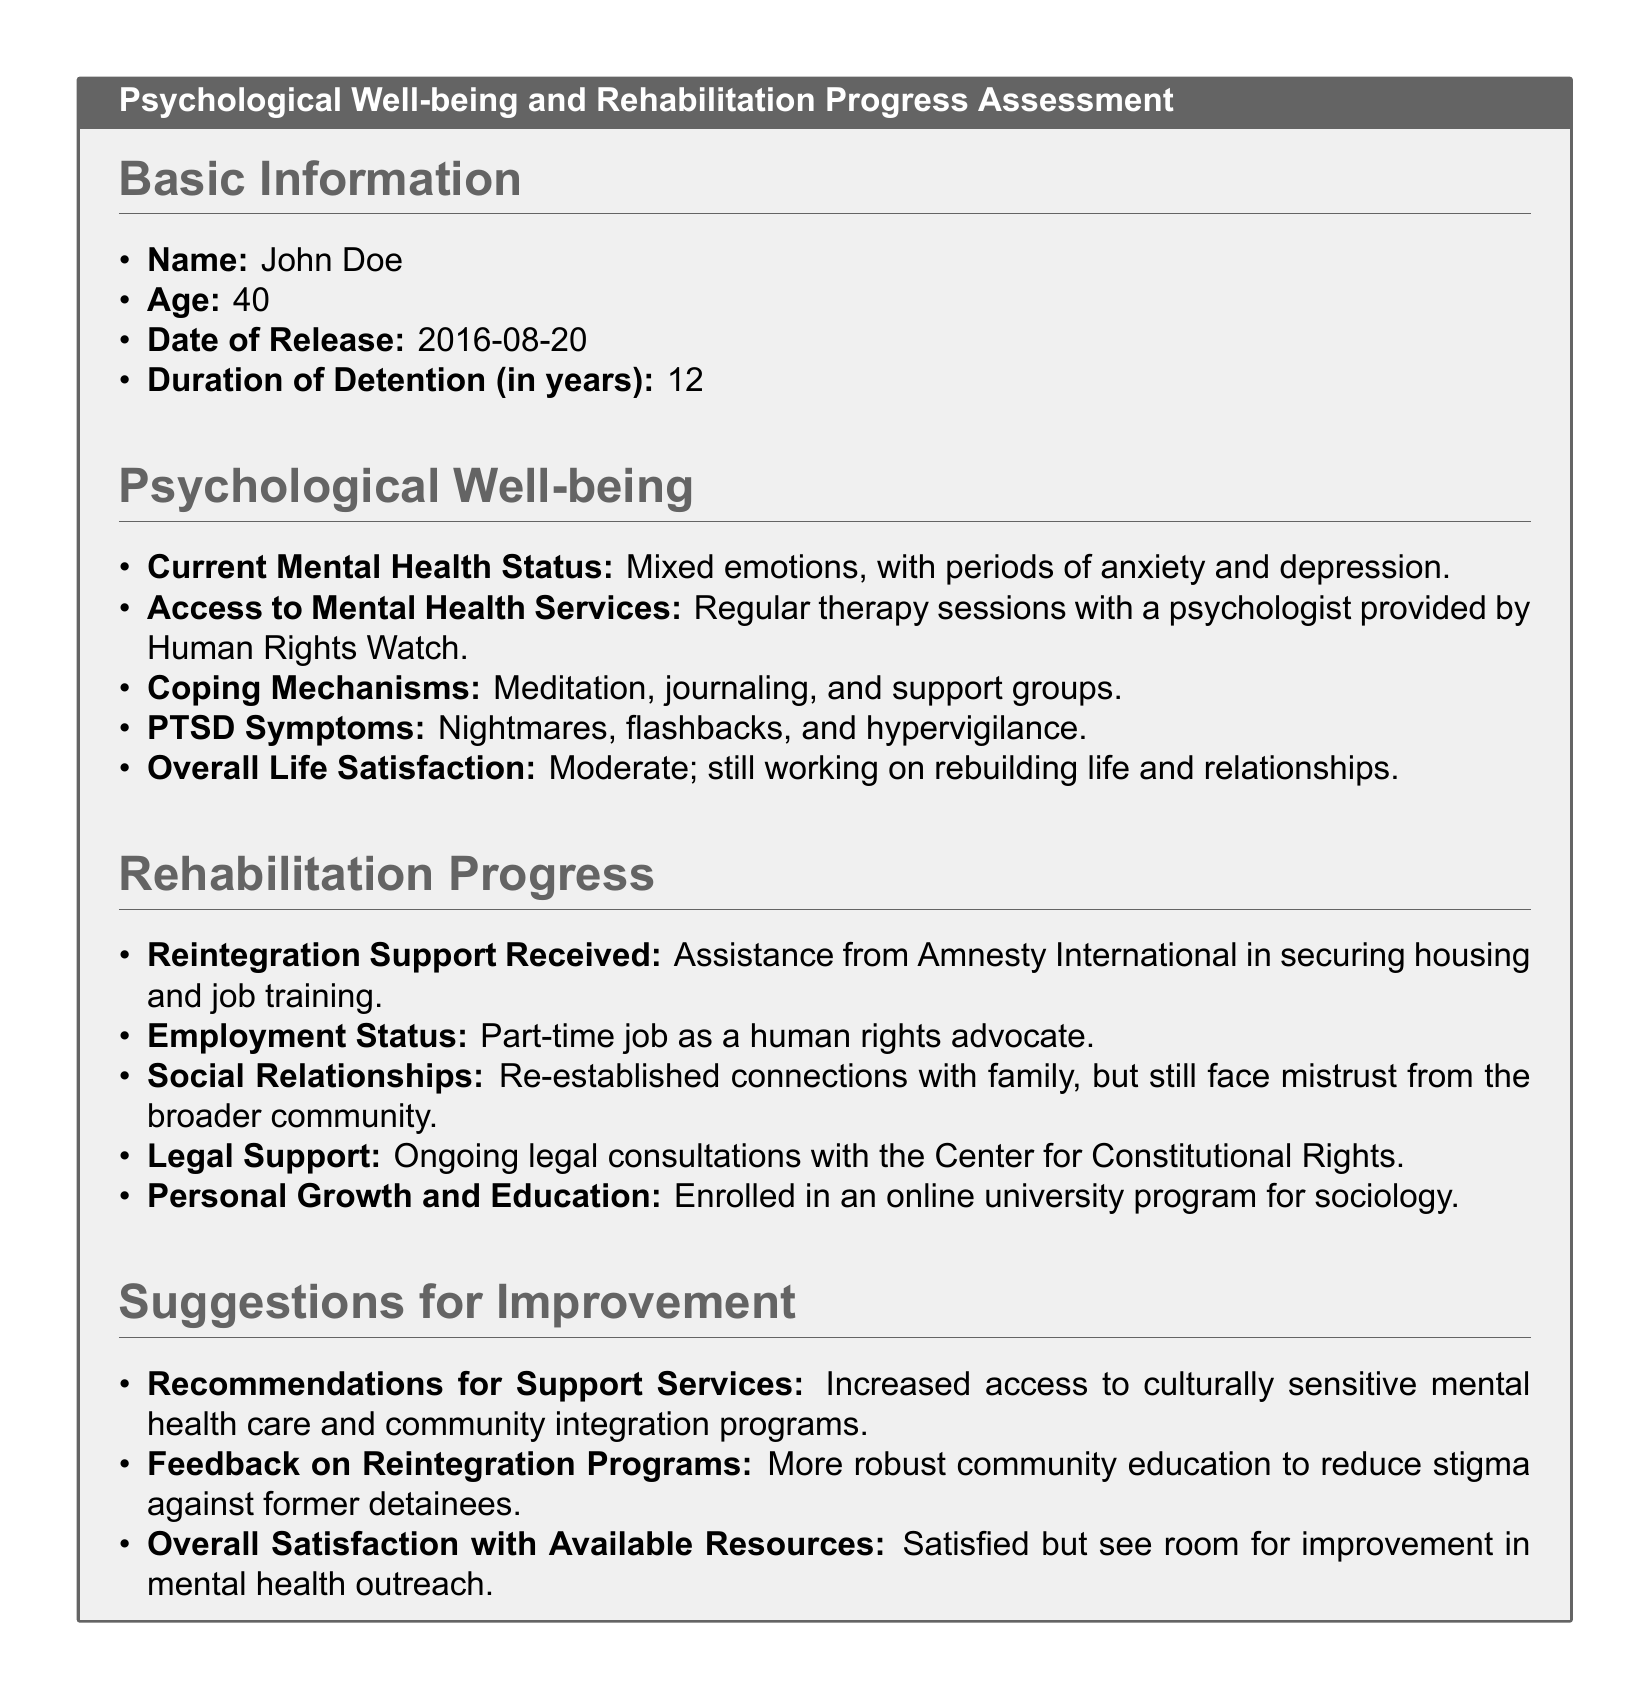What is the name of the individual in the survey? The name field specifies the subject of the survey, which is John Doe.
Answer: John Doe How long was the individual detained? The document states the duration of detention, which is 12 years.
Answer: 12 What is the current mental health status described? The field outlines the mental health condition as mixed emotions, with periods of anxiety and depression.
Answer: Mixed emotions, with periods of anxiety and depression Which organization provides regular therapy sessions? The document identifies Human Rights Watch as the provider of therapy sessions.
Answer: Human Rights Watch What type of job is the individual currently employed in? The survey indicates that the individual has a part-time job as a human rights advocate.
Answer: Part-time job as a human rights advocate What coping mechanisms does the individual employ? The survey details the coping methods used, which include meditation, journaling, and support groups.
Answer: Meditation, journaling, and support groups What is the individual's overall life satisfaction level? The individual reports their overall life satisfaction as moderate, indicating ongoing challenges.
Answer: Moderate What recommendations are made for support services? The document suggests an increased access to culturally sensitive mental health care and community integration programs.
Answer: Increased access to culturally sensitive mental health care and community integration programs What type of educational program is the individual enrolled in? The survey states that the individual is enrolled in an online university program for sociology.
Answer: Online university program for sociology 